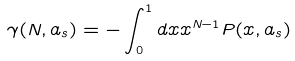<formula> <loc_0><loc_0><loc_500><loc_500>\gamma ( N , a _ { s } ) = - \int _ { 0 } ^ { 1 } d x x ^ { N - 1 } P ( x , a _ { s } )</formula> 